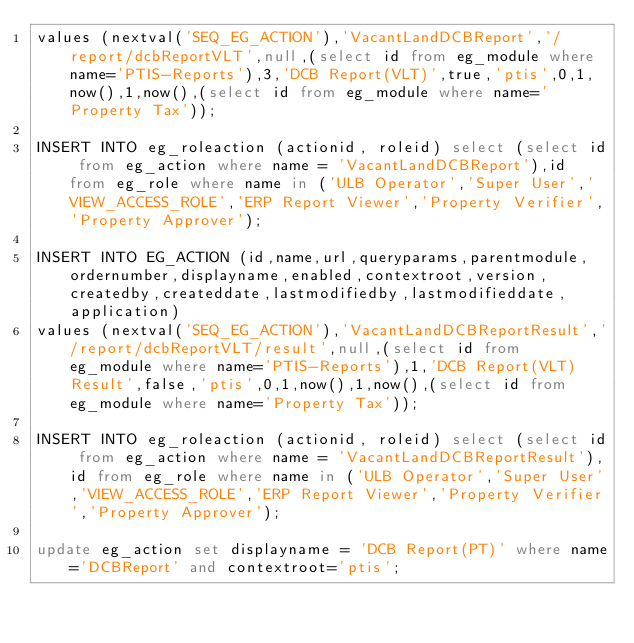Convert code to text. <code><loc_0><loc_0><loc_500><loc_500><_SQL_>values (nextval('SEQ_EG_ACTION'),'VacantLandDCBReport','/report/dcbReportVLT',null,(select id from eg_module where name='PTIS-Reports'),3,'DCB Report(VLT)',true,'ptis',0,1,now(),1,now(),(select id from eg_module where name='Property Tax'));

INSERT INTO eg_roleaction (actionid, roleid) select (select id from eg_action where name = 'VacantLandDCBReport'),id from eg_role where name in ('ULB Operator','Super User','VIEW_ACCESS_ROLE','ERP Report Viewer','Property Verifier','Property Approver');

INSERT INTO EG_ACTION (id,name,url,queryparams,parentmodule,ordernumber,displayname,enabled,contextroot,version,createdby,createddate,lastmodifiedby,lastmodifieddate,application) 
values (nextval('SEQ_EG_ACTION'),'VacantLandDCBReportResult','/report/dcbReportVLT/result',null,(select id from eg_module where name='PTIS-Reports'),1,'DCB Report(VLT) Result',false,'ptis',0,1,now(),1,now(),(select id from eg_module where name='Property Tax'));

INSERT INTO eg_roleaction (actionid, roleid) select (select id from eg_action where name = 'VacantLandDCBReportResult'),id from eg_role where name in ('ULB Operator','Super User','VIEW_ACCESS_ROLE','ERP Report Viewer','Property Verifier','Property Approver');

update eg_action set displayname = 'DCB Report(PT)' where name='DCBReport' and contextroot='ptis';</code> 